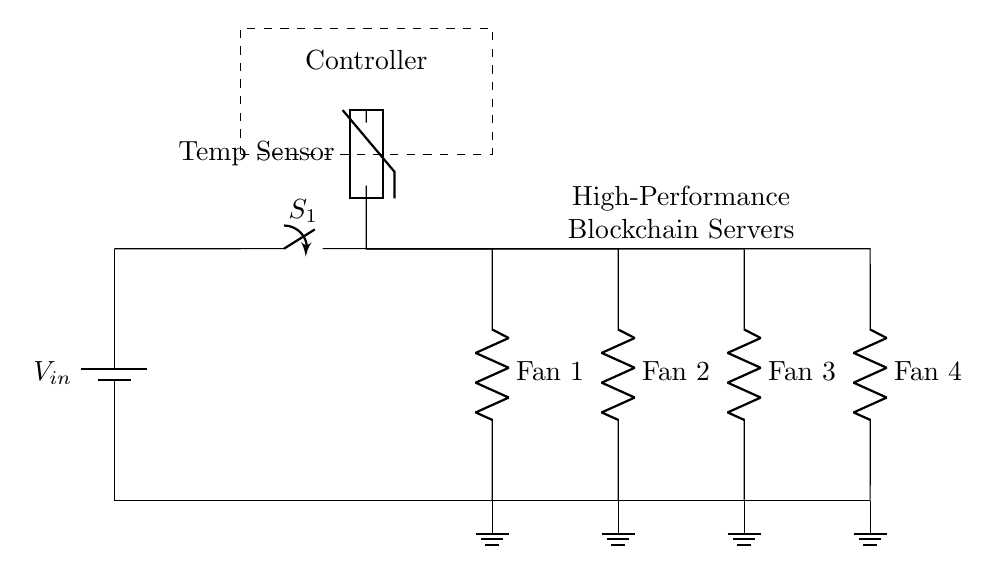What is the input voltage of the circuit? The input voltage is labeled as V_in at the battery, which indicates the source voltage applied to the circuit.
Answer: V_in What type of switch is used in this circuit? The switch is identified as an SPST switch (Single Pole Single Throw), which can either connect or disconnect the circuit.
Answer: SPST How many fans are connected in parallel? There are four fans drawn in the circuit, as indicated by the four parallel branches originating from the same node.
Answer: Four What component measures temperature in this circuit? The temperature measurement is done by a thermistor labeled as a temperature sensor in the schematic.
Answer: Thermistor What is the role of the controller in this circuit? The controller manages the operation of the fans based on temperature readings, located above the main switch and connected to the thermistor.
Answer: Control fans If one fan fails, what happens to the others? In a parallel circuit, if one fan fails, the others continue to operate as the current has multiple paths, allowing advantage of redundancy.
Answer: Continue operating 